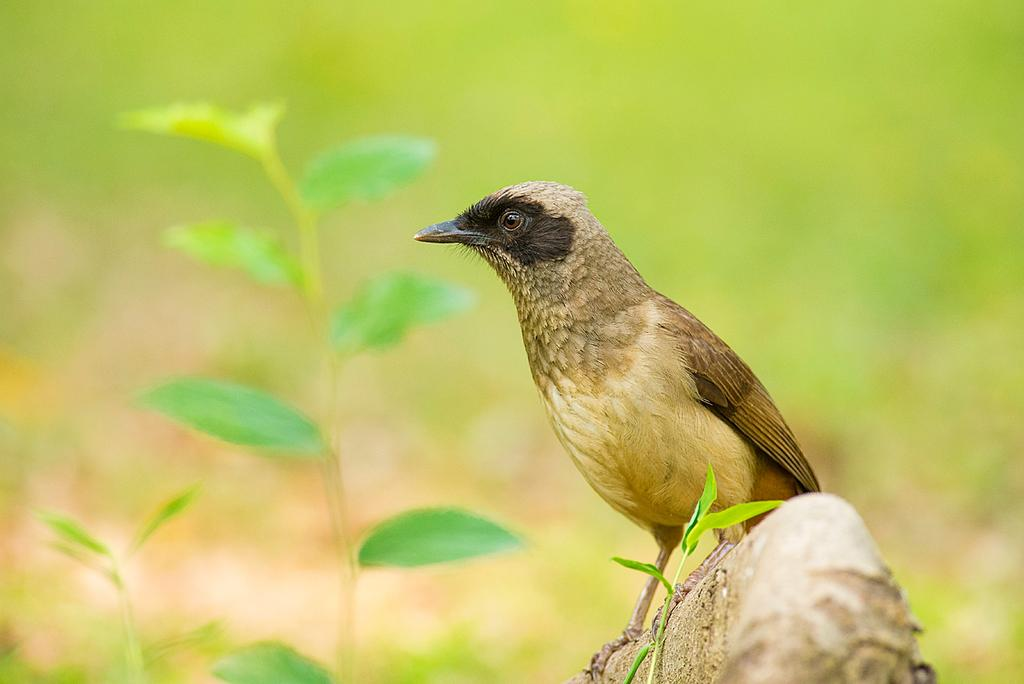What type of animal is in the image? There is a bird in the image. What is the bird standing on? The bird is on wood. What other living organisms can be seen in the image? There are plants in the image. How would you describe the background of the image? The background of the image is blurred. Can you see a ghost in the image? No, there is no ghost present in the image. Is the goose jumping in the image? There is no goose or jumping action depicted in the image; it features a bird on wood with plants and a blurred background. 